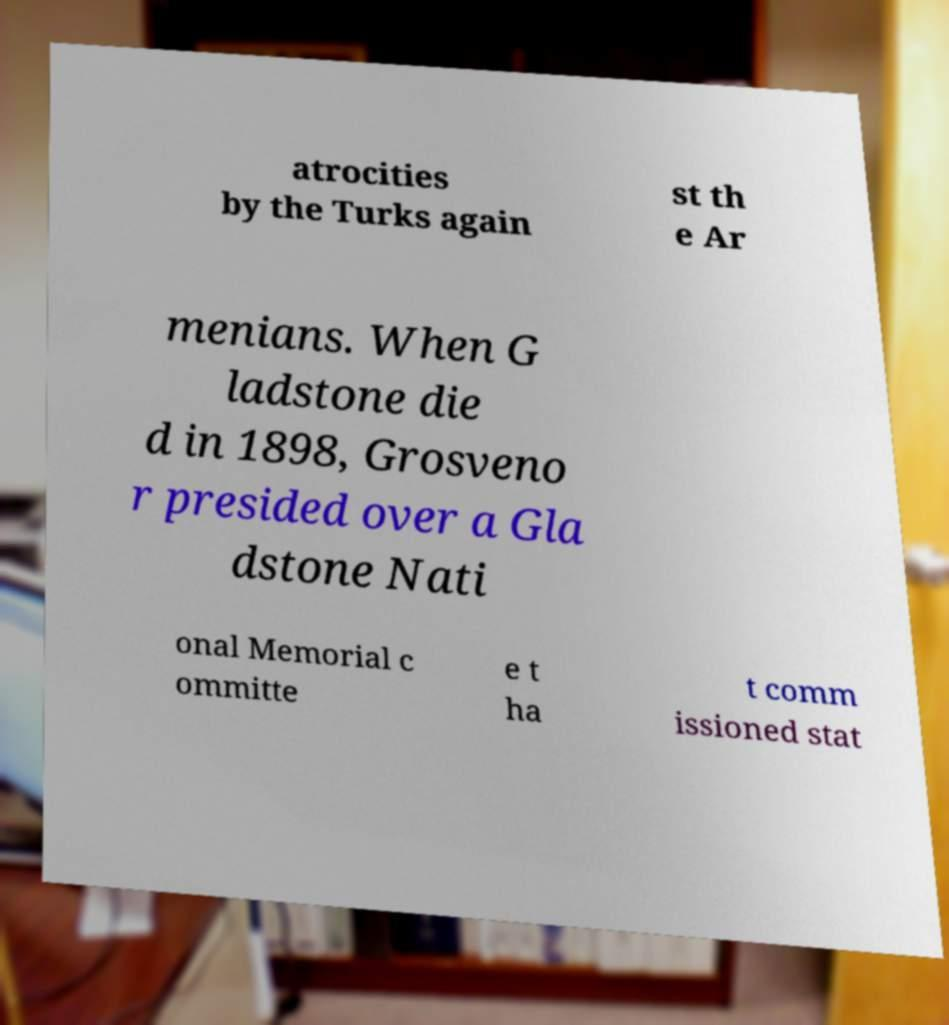For documentation purposes, I need the text within this image transcribed. Could you provide that? atrocities by the Turks again st th e Ar menians. When G ladstone die d in 1898, Grosveno r presided over a Gla dstone Nati onal Memorial c ommitte e t ha t comm issioned stat 